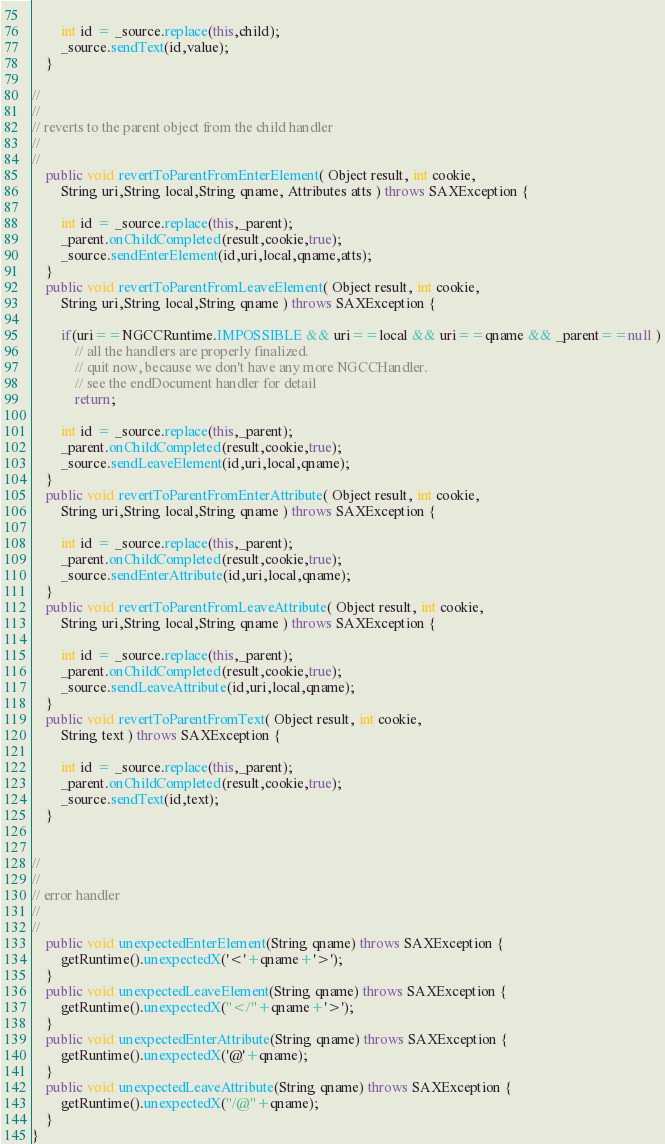Convert code to text. <code><loc_0><loc_0><loc_500><loc_500><_Java_>            
        int id = _source.replace(this,child);
        _source.sendText(id,value);
    }
    
//
//
// reverts to the parent object from the child handler
//
//
    public void revertToParentFromEnterElement( Object result, int cookie,
        String uri,String local,String qname, Attributes atts ) throws SAXException {
            
        int id = _source.replace(this,_parent);
        _parent.onChildCompleted(result,cookie,true);
        _source.sendEnterElement(id,uri,local,qname,atts);
    }
    public void revertToParentFromLeaveElement( Object result, int cookie,
        String uri,String local,String qname ) throws SAXException {
        
        if(uri==NGCCRuntime.IMPOSSIBLE && uri==local && uri==qname && _parent==null )
            // all the handlers are properly finalized.
            // quit now, because we don't have any more NGCCHandler.
            // see the endDocument handler for detail
            return;
        
        int id = _source.replace(this,_parent);
        _parent.onChildCompleted(result,cookie,true);
        _source.sendLeaveElement(id,uri,local,qname);
    }
    public void revertToParentFromEnterAttribute( Object result, int cookie,
        String uri,String local,String qname ) throws SAXException {
            
        int id = _source.replace(this,_parent);
        _parent.onChildCompleted(result,cookie,true);
        _source.sendEnterAttribute(id,uri,local,qname);
    }
    public void revertToParentFromLeaveAttribute( Object result, int cookie,
        String uri,String local,String qname ) throws SAXException {
            
        int id = _source.replace(this,_parent);
        _parent.onChildCompleted(result,cookie,true);
        _source.sendLeaveAttribute(id,uri,local,qname);
    }
    public void revertToParentFromText( Object result, int cookie,
        String text ) throws SAXException {
            
        int id = _source.replace(this,_parent);
        _parent.onChildCompleted(result,cookie,true);
        _source.sendText(id,text);
    }


//
//
// error handler
//
//
    public void unexpectedEnterElement(String qname) throws SAXException {
        getRuntime().unexpectedX('<'+qname+'>');
    }
    public void unexpectedLeaveElement(String qname) throws SAXException {
        getRuntime().unexpectedX("</"+qname+'>');
    }
    public void unexpectedEnterAttribute(String qname) throws SAXException {
        getRuntime().unexpectedX('@'+qname);
    }
    public void unexpectedLeaveAttribute(String qname) throws SAXException {
        getRuntime().unexpectedX("/@"+qname);
    }
}
</code> 